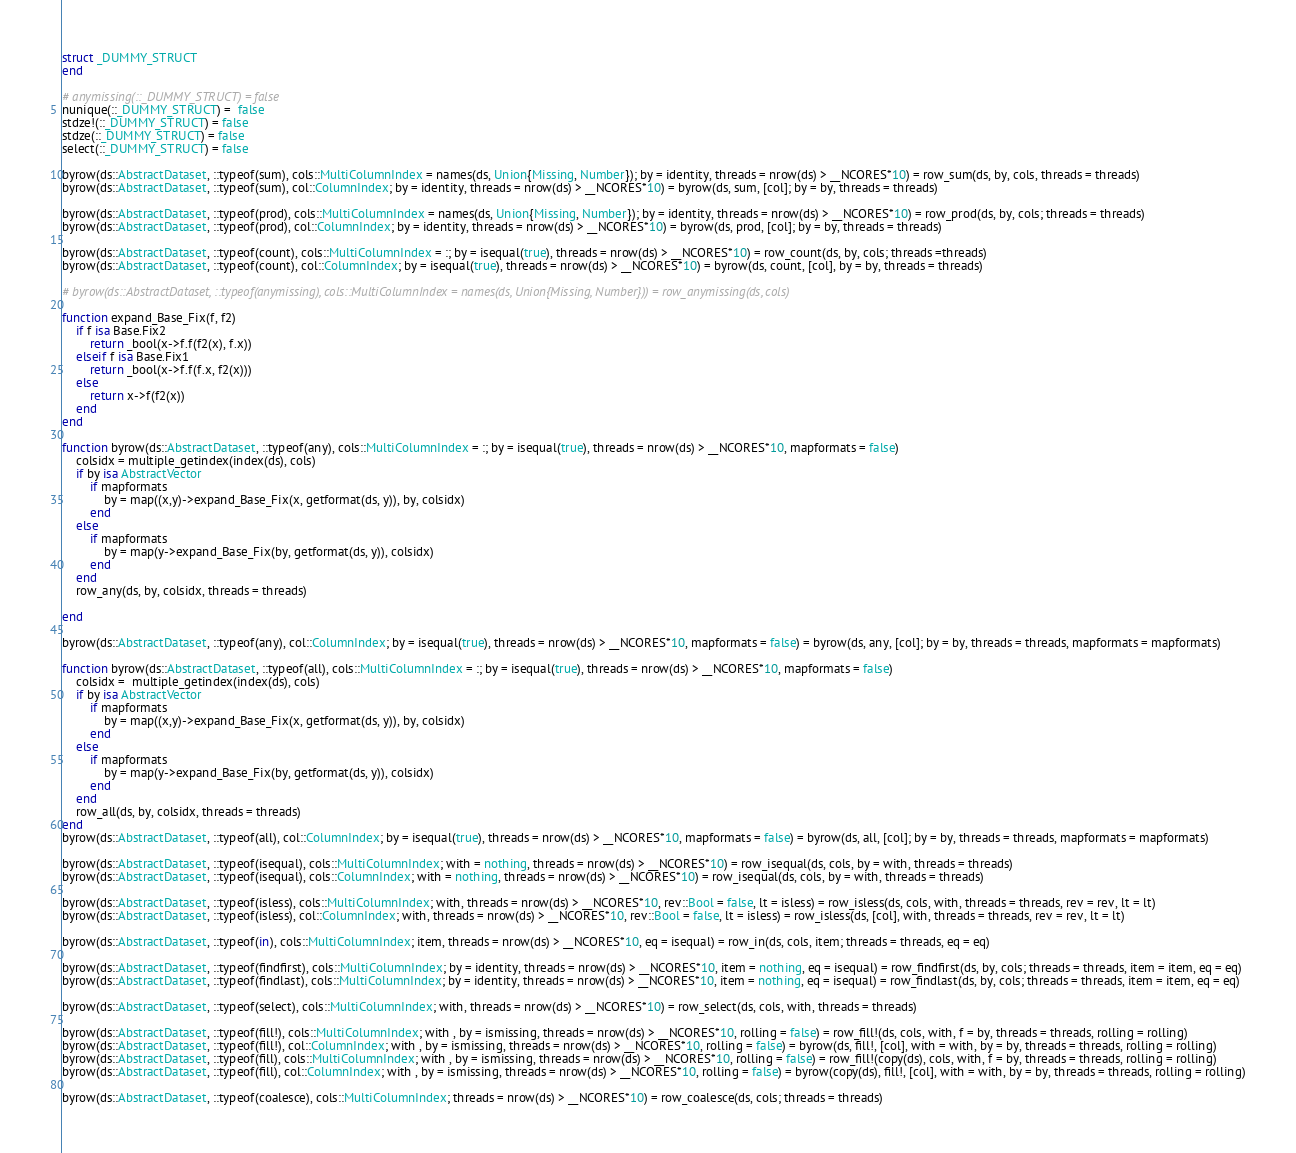<code> <loc_0><loc_0><loc_500><loc_500><_Julia_>struct _DUMMY_STRUCT
end

# anymissing(::_DUMMY_STRUCT) = false
nunique(::_DUMMY_STRUCT) =  false
stdze!(::_DUMMY_STRUCT) = false
stdze(::_DUMMY_STRUCT) = false
select(::_DUMMY_STRUCT) = false

byrow(ds::AbstractDataset, ::typeof(sum), cols::MultiColumnIndex = names(ds, Union{Missing, Number}); by = identity, threads = nrow(ds) > __NCORES*10) = row_sum(ds, by, cols, threads = threads)
byrow(ds::AbstractDataset, ::typeof(sum), col::ColumnIndex; by = identity, threads = nrow(ds) > __NCORES*10) = byrow(ds, sum, [col]; by = by, threads = threads)

byrow(ds::AbstractDataset, ::typeof(prod), cols::MultiColumnIndex = names(ds, Union{Missing, Number}); by = identity, threads = nrow(ds) > __NCORES*10) = row_prod(ds, by, cols; threads = threads)
byrow(ds::AbstractDataset, ::typeof(prod), col::ColumnIndex; by = identity, threads = nrow(ds) > __NCORES*10) = byrow(ds, prod, [col]; by = by, threads = threads)

byrow(ds::AbstractDataset, ::typeof(count), cols::MultiColumnIndex = :; by = isequal(true), threads = nrow(ds) > __NCORES*10) = row_count(ds, by, cols; threads =threads)
byrow(ds::AbstractDataset, ::typeof(count), col::ColumnIndex; by = isequal(true), threads = nrow(ds) > __NCORES*10) = byrow(ds, count, [col], by = by, threads = threads)

# byrow(ds::AbstractDataset, ::typeof(anymissing), cols::MultiColumnIndex = names(ds, Union{Missing, Number})) = row_anymissing(ds, cols)

function expand_Base_Fix(f, f2)
	if f isa Base.Fix2
		return _bool(x->f.f(f2(x), f.x))
	elseif f isa Base.Fix1
		return _bool(x->f.f(f.x, f2(x)))
	else
		return x->f(f2(x))
	end
end

function byrow(ds::AbstractDataset, ::typeof(any), cols::MultiColumnIndex = :; by = isequal(true), threads = nrow(ds) > __NCORES*10, mapformats = false)
	colsidx = multiple_getindex(index(ds), cols)
	if by isa AbstractVector
		if mapformats
			by = map((x,y)->expand_Base_Fix(x, getformat(ds, y)), by, colsidx)
		end
	else
		if mapformats
			by = map(y->expand_Base_Fix(by, getformat(ds, y)), colsidx)
		end
	end
	row_any(ds, by, colsidx, threads = threads)

end

byrow(ds::AbstractDataset, ::typeof(any), col::ColumnIndex; by = isequal(true), threads = nrow(ds) > __NCORES*10, mapformats = false) = byrow(ds, any, [col]; by = by, threads = threads, mapformats = mapformats)

function byrow(ds::AbstractDataset, ::typeof(all), cols::MultiColumnIndex = :; by = isequal(true), threads = nrow(ds) > __NCORES*10, mapformats = false)
	colsidx =  multiple_getindex(index(ds), cols)
	if by isa AbstractVector
		if mapformats
			by = map((x,y)->expand_Base_Fix(x, getformat(ds, y)), by, colsidx)
		end
	else
		if mapformats
			by = map(y->expand_Base_Fix(by, getformat(ds, y)), colsidx)
		end
	end
	row_all(ds, by, colsidx, threads = threads)
end
byrow(ds::AbstractDataset, ::typeof(all), col::ColumnIndex; by = isequal(true), threads = nrow(ds) > __NCORES*10, mapformats = false) = byrow(ds, all, [col]; by = by, threads = threads, mapformats = mapformats)

byrow(ds::AbstractDataset, ::typeof(isequal), cols::MultiColumnIndex; with = nothing, threads = nrow(ds) > __NCORES*10) = row_isequal(ds, cols, by = with, threads = threads)
byrow(ds::AbstractDataset, ::typeof(isequal), cols::ColumnIndex; with = nothing, threads = nrow(ds) > __NCORES*10) = row_isequal(ds, cols, by = with, threads = threads)

byrow(ds::AbstractDataset, ::typeof(isless), cols::MultiColumnIndex; with, threads = nrow(ds) > __NCORES*10, rev::Bool = false, lt = isless) = row_isless(ds, cols, with, threads = threads, rev = rev, lt = lt)
byrow(ds::AbstractDataset, ::typeof(isless), col::ColumnIndex; with, threads = nrow(ds) > __NCORES*10, rev::Bool = false, lt = isless) = row_isless(ds, [col], with, threads = threads, rev = rev, lt = lt)

byrow(ds::AbstractDataset, ::typeof(in), cols::MultiColumnIndex; item, threads = nrow(ds) > __NCORES*10, eq = isequal) = row_in(ds, cols, item; threads = threads, eq = eq)

byrow(ds::AbstractDataset, ::typeof(findfirst), cols::MultiColumnIndex; by = identity, threads = nrow(ds) > __NCORES*10, item = nothing, eq = isequal) = row_findfirst(ds, by, cols; threads = threads, item = item, eq = eq)
byrow(ds::AbstractDataset, ::typeof(findlast), cols::MultiColumnIndex; by = identity, threads = nrow(ds) > __NCORES*10, item = nothing, eq = isequal) = row_findlast(ds, by, cols; threads = threads, item = item, eq = eq)

byrow(ds::AbstractDataset, ::typeof(select), cols::MultiColumnIndex; with, threads = nrow(ds) > __NCORES*10) = row_select(ds, cols, with, threads = threads)

byrow(ds::AbstractDataset, ::typeof(fill!), cols::MultiColumnIndex; with , by = ismissing, threads = nrow(ds) > __NCORES*10, rolling = false) = row_fill!(ds, cols, with, f = by, threads = threads, rolling = rolling)
byrow(ds::AbstractDataset, ::typeof(fill!), col::ColumnIndex; with , by = ismissing, threads = nrow(ds) > __NCORES*10, rolling = false) = byrow(ds, fill!, [col], with = with, by = by, threads = threads, rolling = rolling)
byrow(ds::AbstractDataset, ::typeof(fill), cols::MultiColumnIndex; with , by = ismissing, threads = nrow(ds) > __NCORES*10, rolling = false) = row_fill!(copy(ds), cols, with, f = by, threads = threads, rolling = rolling)
byrow(ds::AbstractDataset, ::typeof(fill), col::ColumnIndex; with , by = ismissing, threads = nrow(ds) > __NCORES*10, rolling = false) = byrow(copy(ds), fill!, [col], with = with, by = by, threads = threads, rolling = rolling)

byrow(ds::AbstractDataset, ::typeof(coalesce), cols::MultiColumnIndex; threads = nrow(ds) > __NCORES*10) = row_coalesce(ds, cols; threads = threads)
</code> 